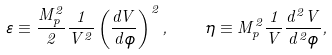Convert formula to latex. <formula><loc_0><loc_0><loc_500><loc_500>\varepsilon \equiv \frac { M _ { p } ^ { 2 } } { 2 } \frac { 1 } { V ^ { 2 } } \left ( \frac { d V } { d \phi } \right ) ^ { 2 } , \quad \eta \equiv M _ { p } ^ { 2 } \frac { 1 } { V } \frac { d ^ { 2 } V } { d ^ { 2 } \phi } ,</formula> 